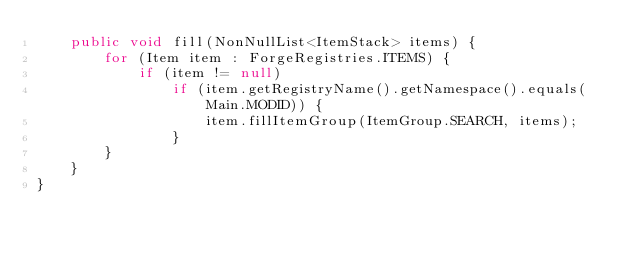<code> <loc_0><loc_0><loc_500><loc_500><_Java_>	public void fill(NonNullList<ItemStack> items) {
		for (Item item : ForgeRegistries.ITEMS) {
			if (item != null)
				if (item.getRegistryName().getNamespace().equals(Main.MODID)) {
					item.fillItemGroup(ItemGroup.SEARCH, items);
				}
		}
	}
}
</code> 